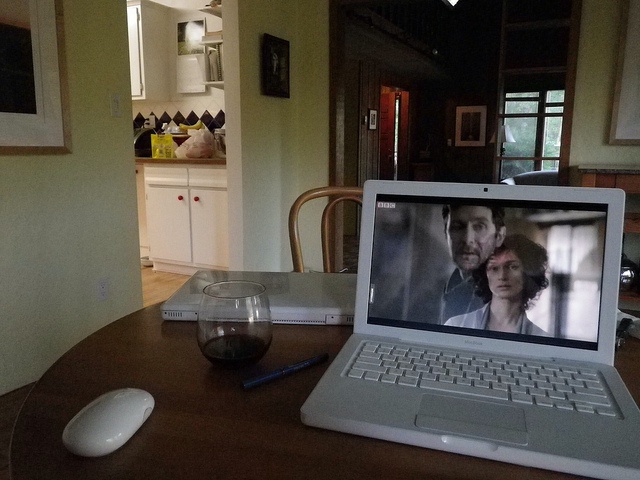Describe the objects in this image and their specific colors. I can see laptop in black and gray tones, dining table in black and gray tones, keyboard in black and gray tones, laptop in black and gray tones, and cup in black, gray, and darkgray tones in this image. 